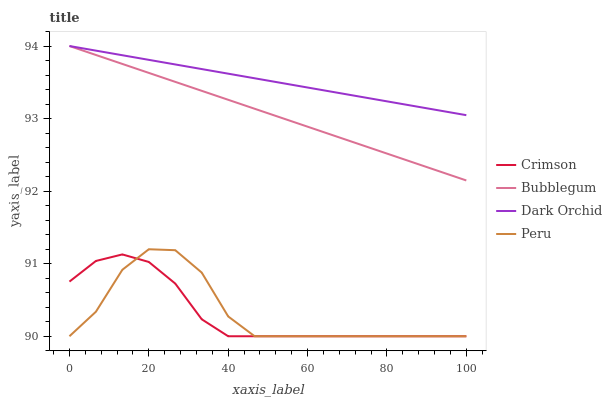Does Peru have the minimum area under the curve?
Answer yes or no. No. Does Peru have the maximum area under the curve?
Answer yes or no. No. Is Peru the smoothest?
Answer yes or no. No. Is Dark Orchid the roughest?
Answer yes or no. No. Does Dark Orchid have the lowest value?
Answer yes or no. No. Does Peru have the highest value?
Answer yes or no. No. Is Peru less than Dark Orchid?
Answer yes or no. Yes. Is Bubblegum greater than Peru?
Answer yes or no. Yes. Does Peru intersect Dark Orchid?
Answer yes or no. No. 